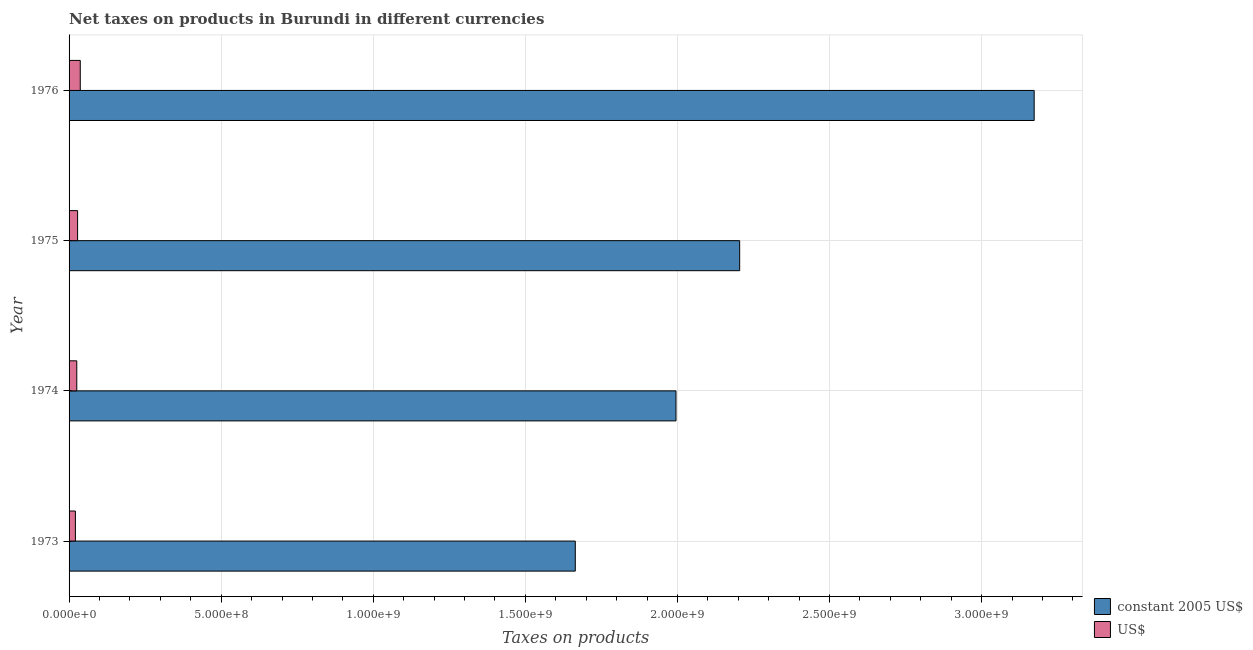How many groups of bars are there?
Make the answer very short. 4. Are the number of bars per tick equal to the number of legend labels?
Offer a terse response. Yes. What is the label of the 1st group of bars from the top?
Ensure brevity in your answer.  1976. What is the net taxes in us$ in 1975?
Offer a terse response. 2.80e+07. Across all years, what is the maximum net taxes in us$?
Provide a succinct answer. 3.68e+07. Across all years, what is the minimum net taxes in constant 2005 us$?
Your answer should be compact. 1.66e+09. In which year was the net taxes in us$ maximum?
Offer a very short reply. 1976. What is the total net taxes in constant 2005 us$ in the graph?
Your answer should be compact. 9.04e+09. What is the difference between the net taxes in constant 2005 us$ in 1975 and that in 1976?
Your response must be concise. -9.68e+08. What is the difference between the net taxes in us$ in 1975 and the net taxes in constant 2005 us$ in 1976?
Your answer should be compact. -3.14e+09. What is the average net taxes in us$ per year?
Offer a terse response. 2.77e+07. In the year 1975, what is the difference between the net taxes in us$ and net taxes in constant 2005 us$?
Your answer should be very brief. -2.18e+09. In how many years, is the net taxes in us$ greater than 3000000000 units?
Keep it short and to the point. 0. What is the ratio of the net taxes in us$ in 1974 to that in 1975?
Your answer should be very brief. 0.91. What is the difference between the highest and the second highest net taxes in constant 2005 us$?
Provide a succinct answer. 9.68e+08. What is the difference between the highest and the lowest net taxes in constant 2005 us$?
Your response must be concise. 1.51e+09. In how many years, is the net taxes in constant 2005 us$ greater than the average net taxes in constant 2005 us$ taken over all years?
Your answer should be compact. 1. What does the 2nd bar from the top in 1975 represents?
Provide a succinct answer. Constant 2005 us$. What does the 1st bar from the bottom in 1974 represents?
Provide a succinct answer. Constant 2005 us$. How many bars are there?
Your answer should be very brief. 8. Are all the bars in the graph horizontal?
Provide a succinct answer. Yes. What is the difference between two consecutive major ticks on the X-axis?
Give a very brief answer. 5.00e+08. Where does the legend appear in the graph?
Make the answer very short. Bottom right. How many legend labels are there?
Make the answer very short. 2. How are the legend labels stacked?
Provide a short and direct response. Vertical. What is the title of the graph?
Offer a terse response. Net taxes on products in Burundi in different currencies. What is the label or title of the X-axis?
Ensure brevity in your answer.  Taxes on products. What is the Taxes on products in constant 2005 US$ in 1973?
Keep it short and to the point. 1.66e+09. What is the Taxes on products in US$ in 1973?
Make the answer very short. 2.08e+07. What is the Taxes on products in constant 2005 US$ in 1974?
Provide a succinct answer. 2.00e+09. What is the Taxes on products of US$ in 1974?
Offer a very short reply. 2.53e+07. What is the Taxes on products in constant 2005 US$ in 1975?
Offer a terse response. 2.20e+09. What is the Taxes on products of US$ in 1975?
Make the answer very short. 2.80e+07. What is the Taxes on products of constant 2005 US$ in 1976?
Provide a short and direct response. 3.17e+09. What is the Taxes on products in US$ in 1976?
Offer a very short reply. 3.68e+07. Across all years, what is the maximum Taxes on products of constant 2005 US$?
Provide a succinct answer. 3.17e+09. Across all years, what is the maximum Taxes on products in US$?
Offer a terse response. 3.68e+07. Across all years, what is the minimum Taxes on products of constant 2005 US$?
Your response must be concise. 1.66e+09. Across all years, what is the minimum Taxes on products in US$?
Give a very brief answer. 2.08e+07. What is the total Taxes on products of constant 2005 US$ in the graph?
Offer a terse response. 9.04e+09. What is the total Taxes on products of US$ in the graph?
Make the answer very short. 1.11e+08. What is the difference between the Taxes on products of constant 2005 US$ in 1973 and that in 1974?
Your response must be concise. -3.31e+08. What is the difference between the Taxes on products in US$ in 1973 and that in 1974?
Keep it short and to the point. -4.54e+06. What is the difference between the Taxes on products of constant 2005 US$ in 1973 and that in 1975?
Your answer should be very brief. -5.40e+08. What is the difference between the Taxes on products of US$ in 1973 and that in 1975?
Your answer should be compact. -7.20e+06. What is the difference between the Taxes on products in constant 2005 US$ in 1973 and that in 1976?
Offer a very short reply. -1.51e+09. What is the difference between the Taxes on products in US$ in 1973 and that in 1976?
Provide a succinct answer. -1.60e+07. What is the difference between the Taxes on products in constant 2005 US$ in 1974 and that in 1975?
Provide a succinct answer. -2.09e+08. What is the difference between the Taxes on products of US$ in 1974 and that in 1975?
Your answer should be very brief. -2.66e+06. What is the difference between the Taxes on products of constant 2005 US$ in 1974 and that in 1976?
Provide a succinct answer. -1.18e+09. What is the difference between the Taxes on products of US$ in 1974 and that in 1976?
Give a very brief answer. -1.14e+07. What is the difference between the Taxes on products in constant 2005 US$ in 1975 and that in 1976?
Offer a terse response. -9.68e+08. What is the difference between the Taxes on products of US$ in 1975 and that in 1976?
Give a very brief answer. -8.79e+06. What is the difference between the Taxes on products of constant 2005 US$ in 1973 and the Taxes on products of US$ in 1974?
Provide a succinct answer. 1.64e+09. What is the difference between the Taxes on products of constant 2005 US$ in 1973 and the Taxes on products of US$ in 1975?
Make the answer very short. 1.64e+09. What is the difference between the Taxes on products in constant 2005 US$ in 1973 and the Taxes on products in US$ in 1976?
Keep it short and to the point. 1.63e+09. What is the difference between the Taxes on products of constant 2005 US$ in 1974 and the Taxes on products of US$ in 1975?
Offer a very short reply. 1.97e+09. What is the difference between the Taxes on products in constant 2005 US$ in 1974 and the Taxes on products in US$ in 1976?
Your response must be concise. 1.96e+09. What is the difference between the Taxes on products of constant 2005 US$ in 1975 and the Taxes on products of US$ in 1976?
Your answer should be compact. 2.17e+09. What is the average Taxes on products of constant 2005 US$ per year?
Provide a short and direct response. 2.26e+09. What is the average Taxes on products in US$ per year?
Offer a very short reply. 2.77e+07. In the year 1973, what is the difference between the Taxes on products in constant 2005 US$ and Taxes on products in US$?
Your answer should be compact. 1.64e+09. In the year 1974, what is the difference between the Taxes on products of constant 2005 US$ and Taxes on products of US$?
Your answer should be very brief. 1.97e+09. In the year 1975, what is the difference between the Taxes on products of constant 2005 US$ and Taxes on products of US$?
Offer a terse response. 2.18e+09. In the year 1976, what is the difference between the Taxes on products of constant 2005 US$ and Taxes on products of US$?
Offer a terse response. 3.14e+09. What is the ratio of the Taxes on products in constant 2005 US$ in 1973 to that in 1974?
Your response must be concise. 0.83. What is the ratio of the Taxes on products of US$ in 1973 to that in 1974?
Make the answer very short. 0.82. What is the ratio of the Taxes on products of constant 2005 US$ in 1973 to that in 1975?
Ensure brevity in your answer.  0.75. What is the ratio of the Taxes on products of US$ in 1973 to that in 1975?
Give a very brief answer. 0.74. What is the ratio of the Taxes on products of constant 2005 US$ in 1973 to that in 1976?
Your answer should be very brief. 0.52. What is the ratio of the Taxes on products in US$ in 1973 to that in 1976?
Your answer should be very brief. 0.57. What is the ratio of the Taxes on products of constant 2005 US$ in 1974 to that in 1975?
Offer a very short reply. 0.91. What is the ratio of the Taxes on products of US$ in 1974 to that in 1975?
Provide a short and direct response. 0.91. What is the ratio of the Taxes on products in constant 2005 US$ in 1974 to that in 1976?
Make the answer very short. 0.63. What is the ratio of the Taxes on products in US$ in 1974 to that in 1976?
Provide a succinct answer. 0.69. What is the ratio of the Taxes on products in constant 2005 US$ in 1975 to that in 1976?
Provide a succinct answer. 0.69. What is the ratio of the Taxes on products of US$ in 1975 to that in 1976?
Give a very brief answer. 0.76. What is the difference between the highest and the second highest Taxes on products in constant 2005 US$?
Your response must be concise. 9.68e+08. What is the difference between the highest and the second highest Taxes on products in US$?
Make the answer very short. 8.79e+06. What is the difference between the highest and the lowest Taxes on products of constant 2005 US$?
Your response must be concise. 1.51e+09. What is the difference between the highest and the lowest Taxes on products of US$?
Your response must be concise. 1.60e+07. 